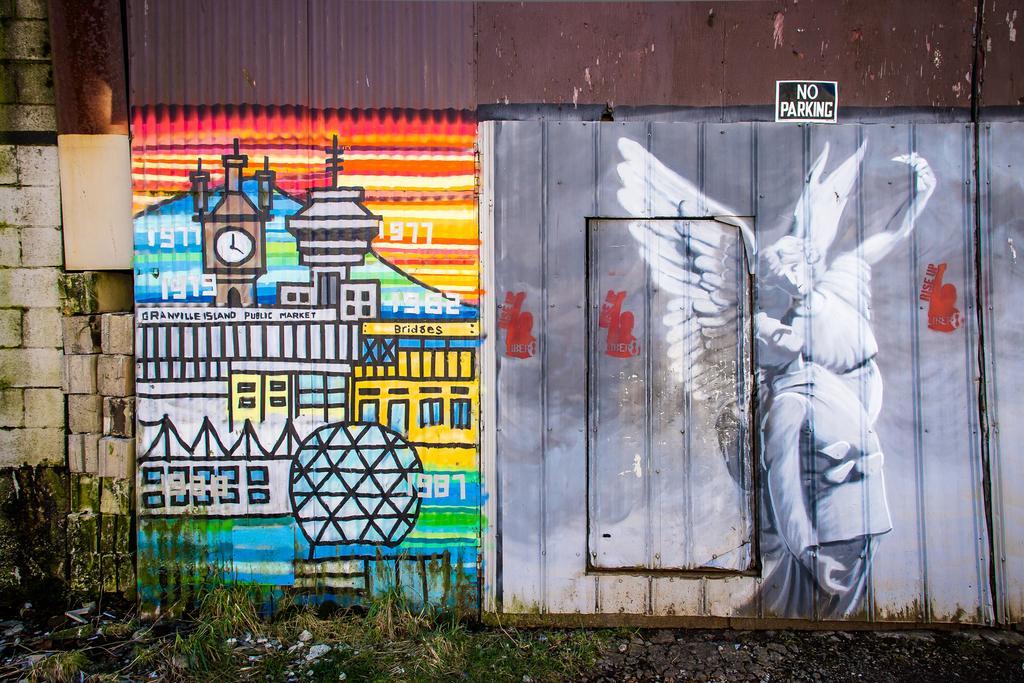In one or two sentences, can you explain what this image depicts? In this image I can see a wall and on it I can see different types of painting. I can also see no parking is written over here. 